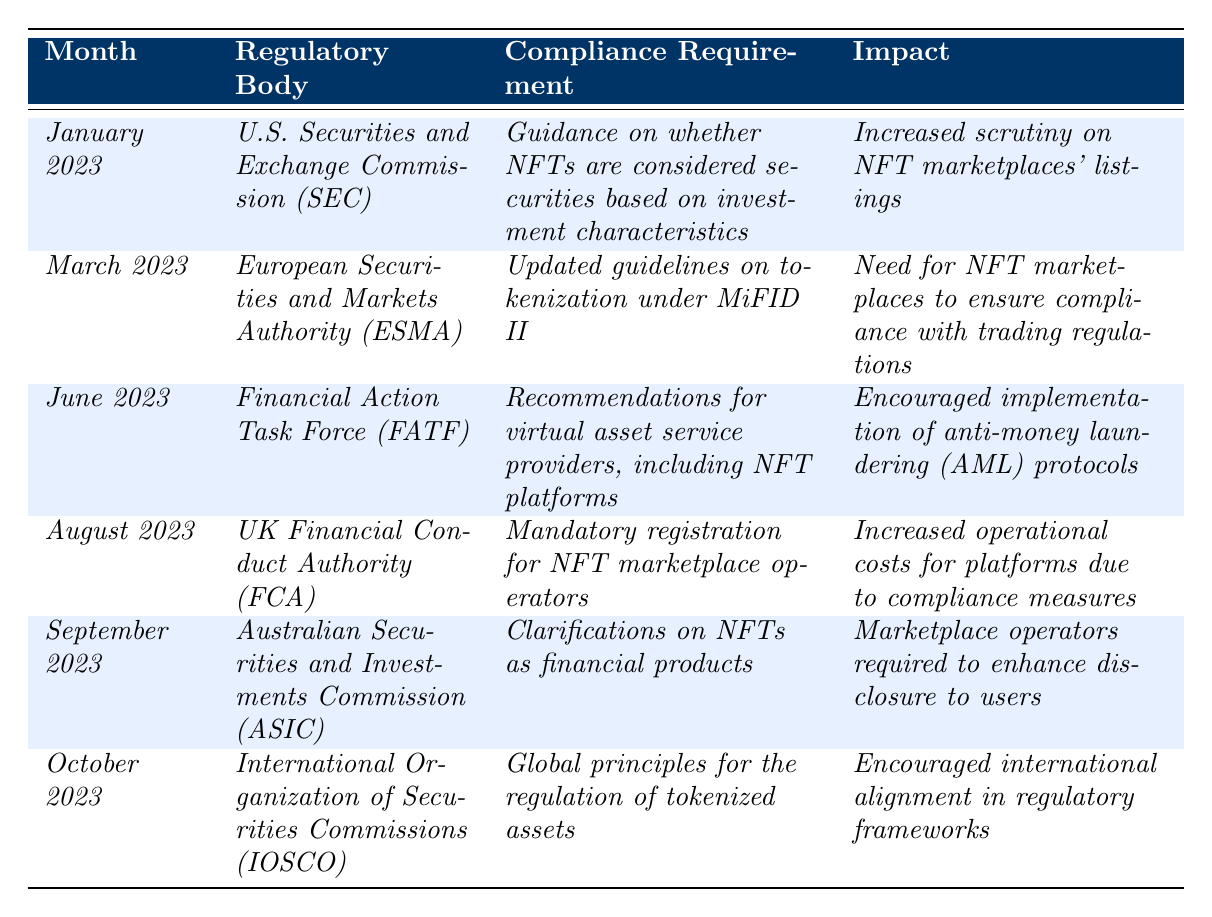What regulatory body provided guidance on NFTs in January 2023? The table indicates that the U.S. Securities and Exchange Commission (SEC) provided guidance regarding whether NFTs are considered securities based on investment characteristics in January 2023.
Answer: U.S. Securities and Exchange Commission (SEC) What was the impact of the guidance from the SEC in January 2023? According to the table, the impact was increased scrutiny on NFT marketplaces' listings, indicating a more careful examination of what NFTs are offered.
Answer: Increased scrutiny on NFT marketplaces' listings How many regulatory bodies are mentioned in the table? The table lists six regulatory bodies: SEC, ESMA, FATF, FCA, ASIC, and IOSCO, totaling six.
Answer: Six What are the compliance requirements set by the UK Financial Conduct Authority (FCA) in August 2023? The FCA's compliance requirement was mandatory registration for NFT marketplace operators, as presented in the table for August 2023.
Answer: Mandatory registration for NFT marketplace operators Which month had the highest number of regulations affecting NFT marketplaces? Each month has one regulatory update, so no month stands out based on frequency; all months have one update each, resulting in the same impact across them.
Answer: None, all months are equal What clarifications were provided by the Australian Securities and Investments Commission (ASIC) in September 2023? The ASIC provided clarifications on NFTs as financial products, which is detailed in the table under September 2023.
Answer: Clarifications on NFTs as financial products Did the Financial Action Task Force (FATF) provide recommendations for NFT platforms in June 2023? Yes, the table confirms that the FATF made recommendations for virtual asset service providers, including NFT platforms, in June 2023.
Answer: Yes What was the primary focus of the International Organization of Securities Commissions (IOSCO) in October 2023? The IOSCO focused on establishing global principles for the regulation of tokenized assets, facilitating international coherence in regulations.
Answer: Global principles for the regulation of tokenized assets What trend relates to increased operational costs for NFT platforms? The mandatory registration for NFT marketplace operators set forth by the FCA in August 2023 is associated with increased operational costs for platforms, as mentioned in the table.
Answer: Mandatory registration by FCA Summarize the compliance evolution concerning NFT marketplaces from January to October 2023. The compliance evolution shows a progression from guidance on security classification in January, to operational guidelines and registration requirements, with increasing regulatory scrutiny and international alignment by October.
Answer: Increasing scrutiny and international alignment in regulatory frameworks 